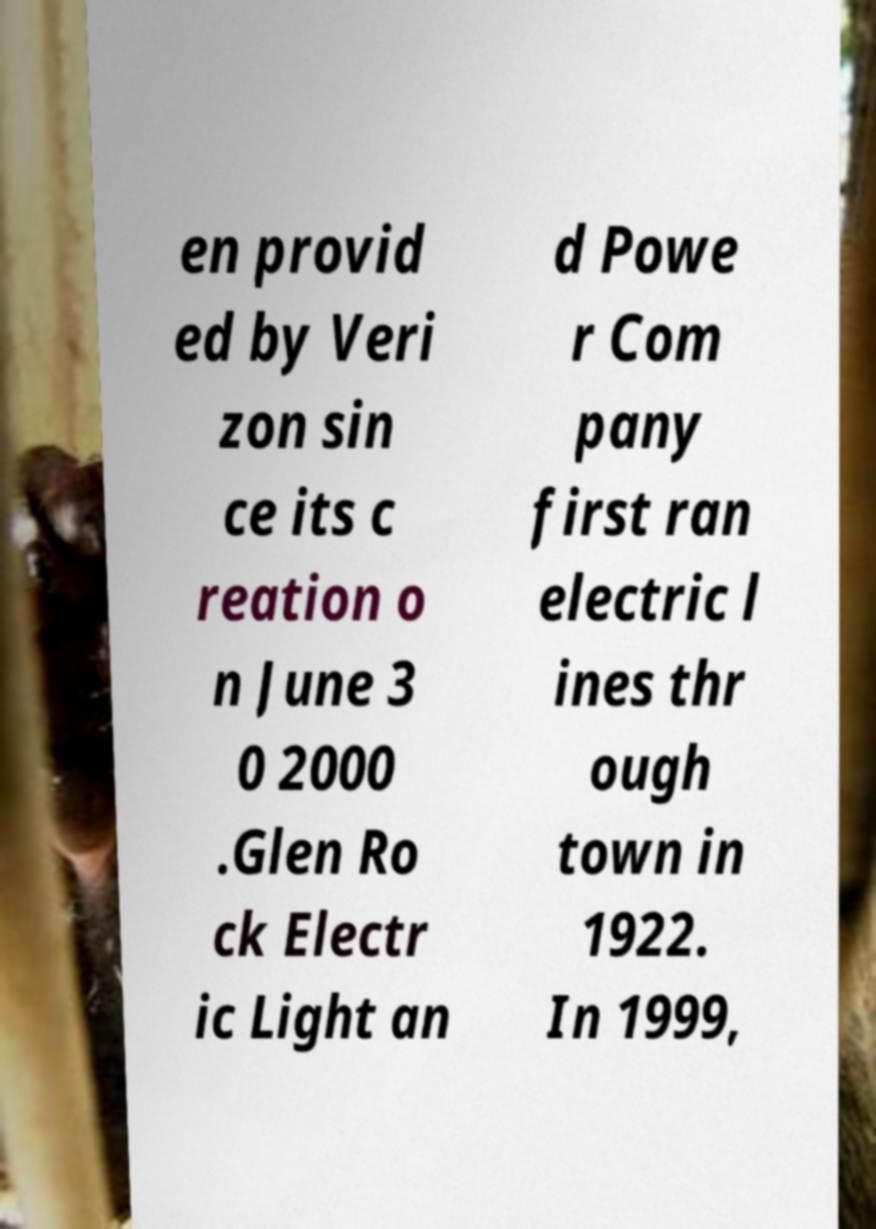Can you read and provide the text displayed in the image?This photo seems to have some interesting text. Can you extract and type it out for me? en provid ed by Veri zon sin ce its c reation o n June 3 0 2000 .Glen Ro ck Electr ic Light an d Powe r Com pany first ran electric l ines thr ough town in 1922. In 1999, 